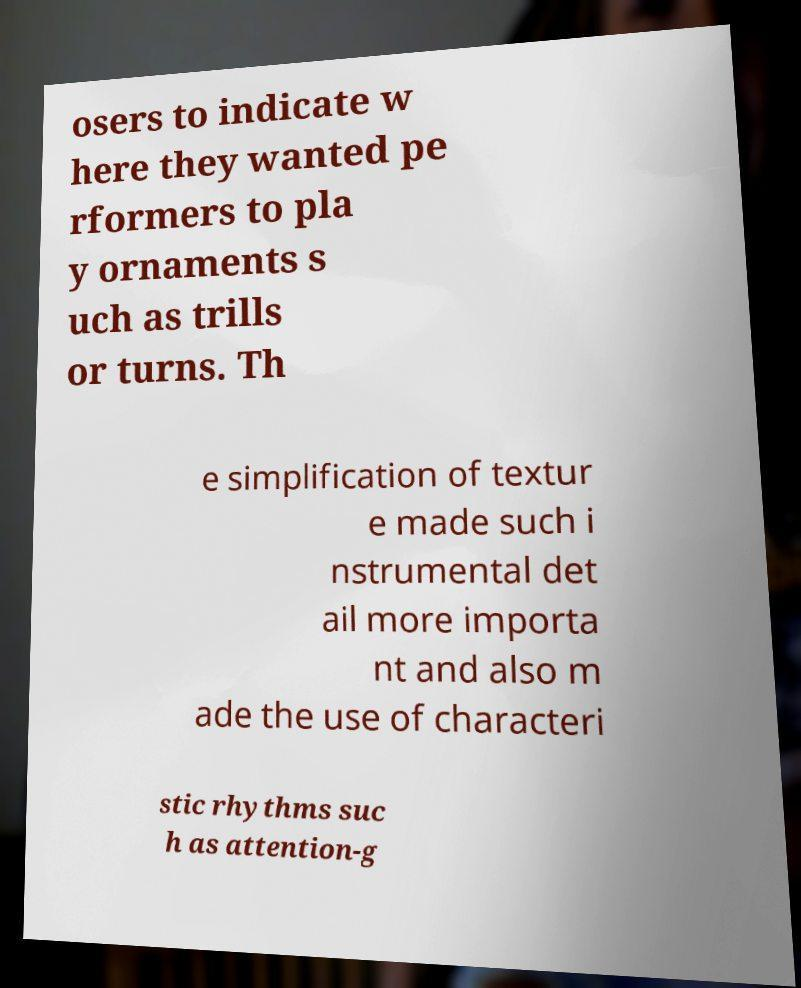Can you accurately transcribe the text from the provided image for me? osers to indicate w here they wanted pe rformers to pla y ornaments s uch as trills or turns. Th e simplification of textur e made such i nstrumental det ail more importa nt and also m ade the use of characteri stic rhythms suc h as attention-g 